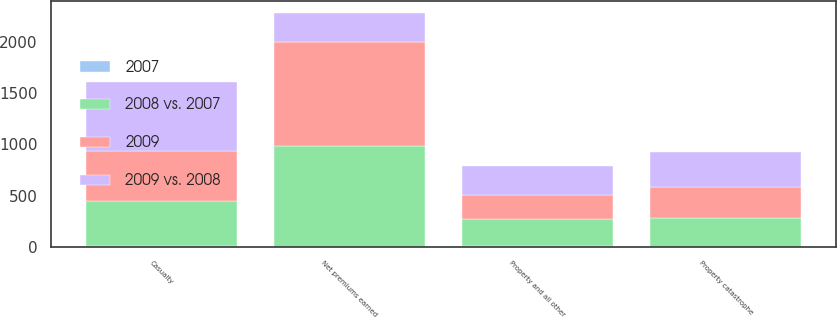<chart> <loc_0><loc_0><loc_500><loc_500><stacked_bar_chart><ecel><fcel>Property and all other<fcel>Casualty<fcel>Property catastrophe<fcel>Net premiums earned<nl><fcel>2008 vs. 2007<fcel>262<fcel>433<fcel>284<fcel>979<nl><fcel>2009<fcel>229<fcel>494<fcel>294<fcel>1017<nl><fcel>2009 vs. 2008<fcel>285<fcel>671<fcel>343<fcel>285<nl><fcel>2007<fcel>14<fcel>12<fcel>3<fcel>4<nl></chart> 